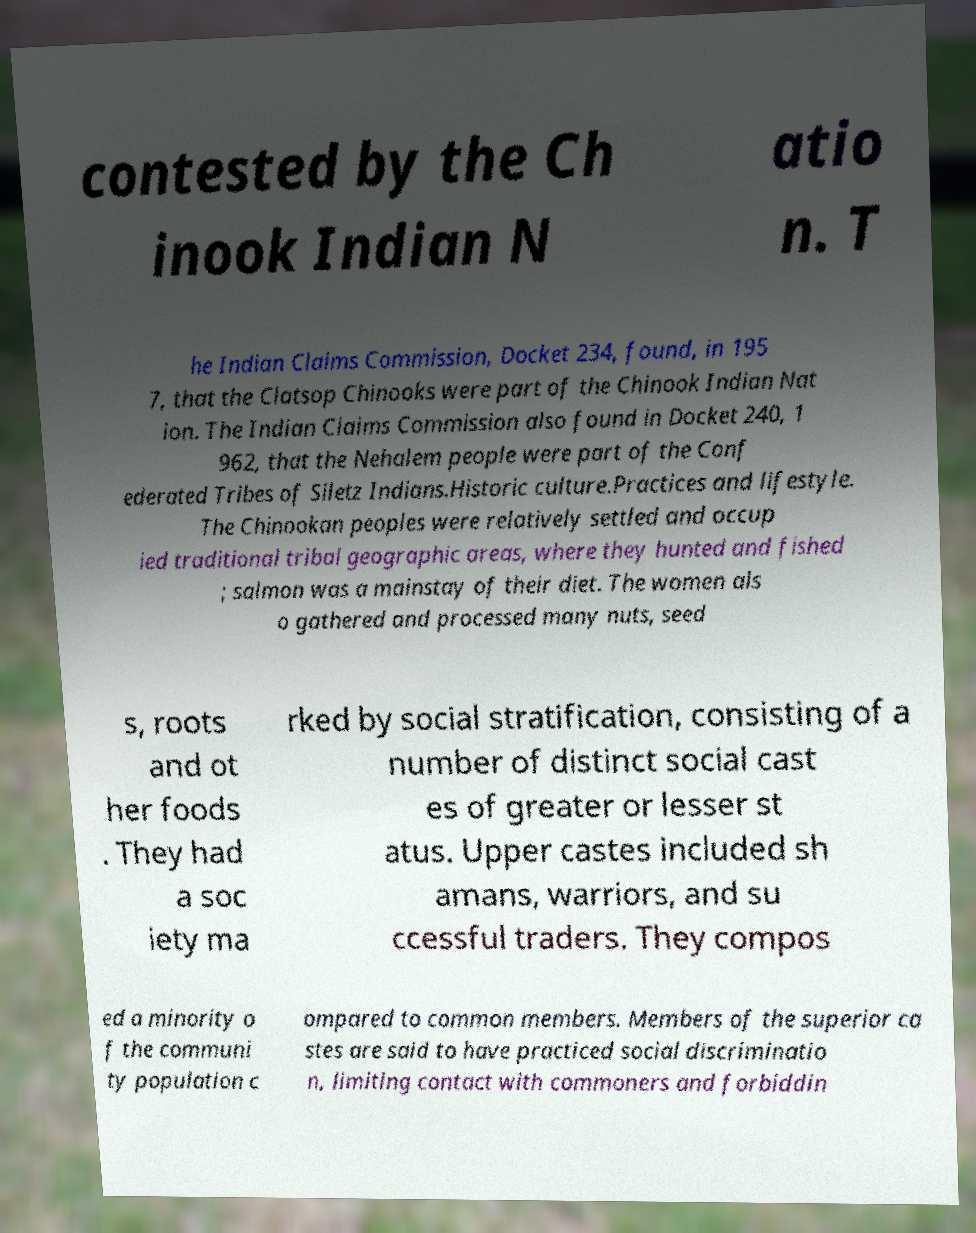Can you read and provide the text displayed in the image?This photo seems to have some interesting text. Can you extract and type it out for me? contested by the Ch inook Indian N atio n. T he Indian Claims Commission, Docket 234, found, in 195 7, that the Clatsop Chinooks were part of the Chinook Indian Nat ion. The Indian Claims Commission also found in Docket 240, 1 962, that the Nehalem people were part of the Conf ederated Tribes of Siletz Indians.Historic culture.Practices and lifestyle. The Chinookan peoples were relatively settled and occup ied traditional tribal geographic areas, where they hunted and fished ; salmon was a mainstay of their diet. The women als o gathered and processed many nuts, seed s, roots and ot her foods . They had a soc iety ma rked by social stratification, consisting of a number of distinct social cast es of greater or lesser st atus. Upper castes included sh amans, warriors, and su ccessful traders. They compos ed a minority o f the communi ty population c ompared to common members. Members of the superior ca stes are said to have practiced social discriminatio n, limiting contact with commoners and forbiddin 